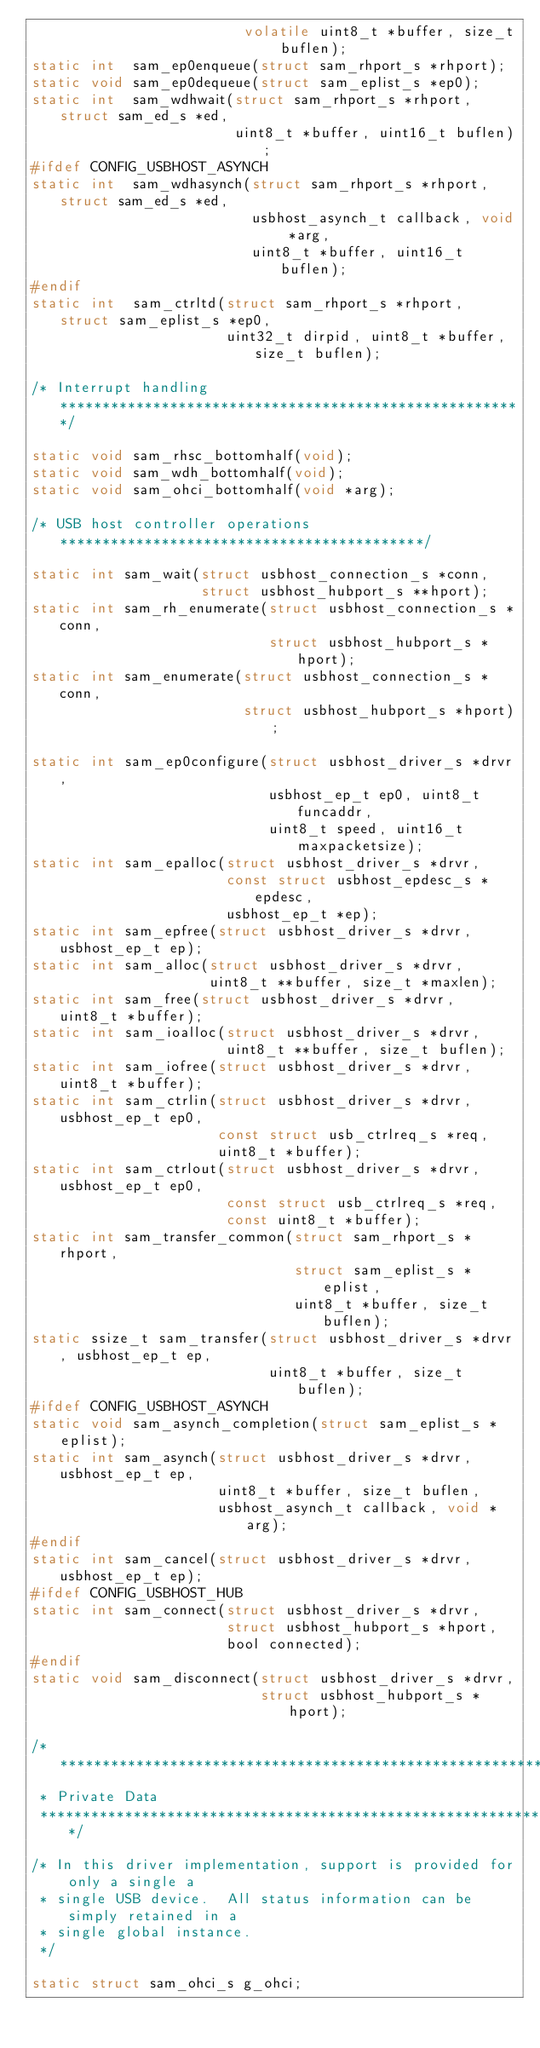<code> <loc_0><loc_0><loc_500><loc_500><_C_>                         volatile uint8_t *buffer, size_t buflen);
static int  sam_ep0enqueue(struct sam_rhport_s *rhport);
static void sam_ep0dequeue(struct sam_eplist_s *ep0);
static int  sam_wdhwait(struct sam_rhport_s *rhport, struct sam_ed_s *ed,
                        uint8_t *buffer, uint16_t buflen);
#ifdef CONFIG_USBHOST_ASYNCH
static int  sam_wdhasynch(struct sam_rhport_s *rhport, struct sam_ed_s *ed,
                          usbhost_asynch_t callback, void *arg,
                          uint8_t *buffer, uint16_t buflen);
#endif
static int  sam_ctrltd(struct sam_rhport_s *rhport, struct sam_eplist_s *ep0,
                       uint32_t dirpid, uint8_t *buffer, size_t buflen);

/* Interrupt handling *******************************************************/

static void sam_rhsc_bottomhalf(void);
static void sam_wdh_bottomhalf(void);
static void sam_ohci_bottomhalf(void *arg);

/* USB host controller operations *******************************************/

static int sam_wait(struct usbhost_connection_s *conn,
                    struct usbhost_hubport_s **hport);
static int sam_rh_enumerate(struct usbhost_connection_s *conn,
                            struct usbhost_hubport_s *hport);
static int sam_enumerate(struct usbhost_connection_s *conn,
                         struct usbhost_hubport_s *hport);

static int sam_ep0configure(struct usbhost_driver_s *drvr,
                            usbhost_ep_t ep0, uint8_t funcaddr,
                            uint8_t speed, uint16_t maxpacketsize);
static int sam_epalloc(struct usbhost_driver_s *drvr,
                       const struct usbhost_epdesc_s *epdesc,
                       usbhost_ep_t *ep);
static int sam_epfree(struct usbhost_driver_s *drvr, usbhost_ep_t ep);
static int sam_alloc(struct usbhost_driver_s *drvr,
                     uint8_t **buffer, size_t *maxlen);
static int sam_free(struct usbhost_driver_s *drvr, uint8_t *buffer);
static int sam_ioalloc(struct usbhost_driver_s *drvr,
                       uint8_t **buffer, size_t buflen);
static int sam_iofree(struct usbhost_driver_s *drvr, uint8_t *buffer);
static int sam_ctrlin(struct usbhost_driver_s *drvr, usbhost_ep_t ep0,
                      const struct usb_ctrlreq_s *req,
                      uint8_t *buffer);
static int sam_ctrlout(struct usbhost_driver_s *drvr, usbhost_ep_t ep0,
                       const struct usb_ctrlreq_s *req,
                       const uint8_t *buffer);
static int sam_transfer_common(struct sam_rhport_s *rhport,
                               struct sam_eplist_s *eplist,
                               uint8_t *buffer, size_t buflen);
static ssize_t sam_transfer(struct usbhost_driver_s *drvr, usbhost_ep_t ep,
                            uint8_t *buffer, size_t buflen);
#ifdef CONFIG_USBHOST_ASYNCH
static void sam_asynch_completion(struct sam_eplist_s *eplist);
static int sam_asynch(struct usbhost_driver_s *drvr, usbhost_ep_t ep,
                      uint8_t *buffer, size_t buflen,
                      usbhost_asynch_t callback, void *arg);
#endif
static int sam_cancel(struct usbhost_driver_s *drvr, usbhost_ep_t ep);
#ifdef CONFIG_USBHOST_HUB
static int sam_connect(struct usbhost_driver_s *drvr,
                       struct usbhost_hubport_s *hport,
                       bool connected);
#endif
static void sam_disconnect(struct usbhost_driver_s *drvr,
                           struct usbhost_hubport_s *hport);

/****************************************************************************
 * Private Data
 ****************************************************************************/

/* In this driver implementation, support is provided for only a single a
 * single USB device.  All status information can be simply retained in a
 * single global instance.
 */

static struct sam_ohci_s g_ohci;
</code> 